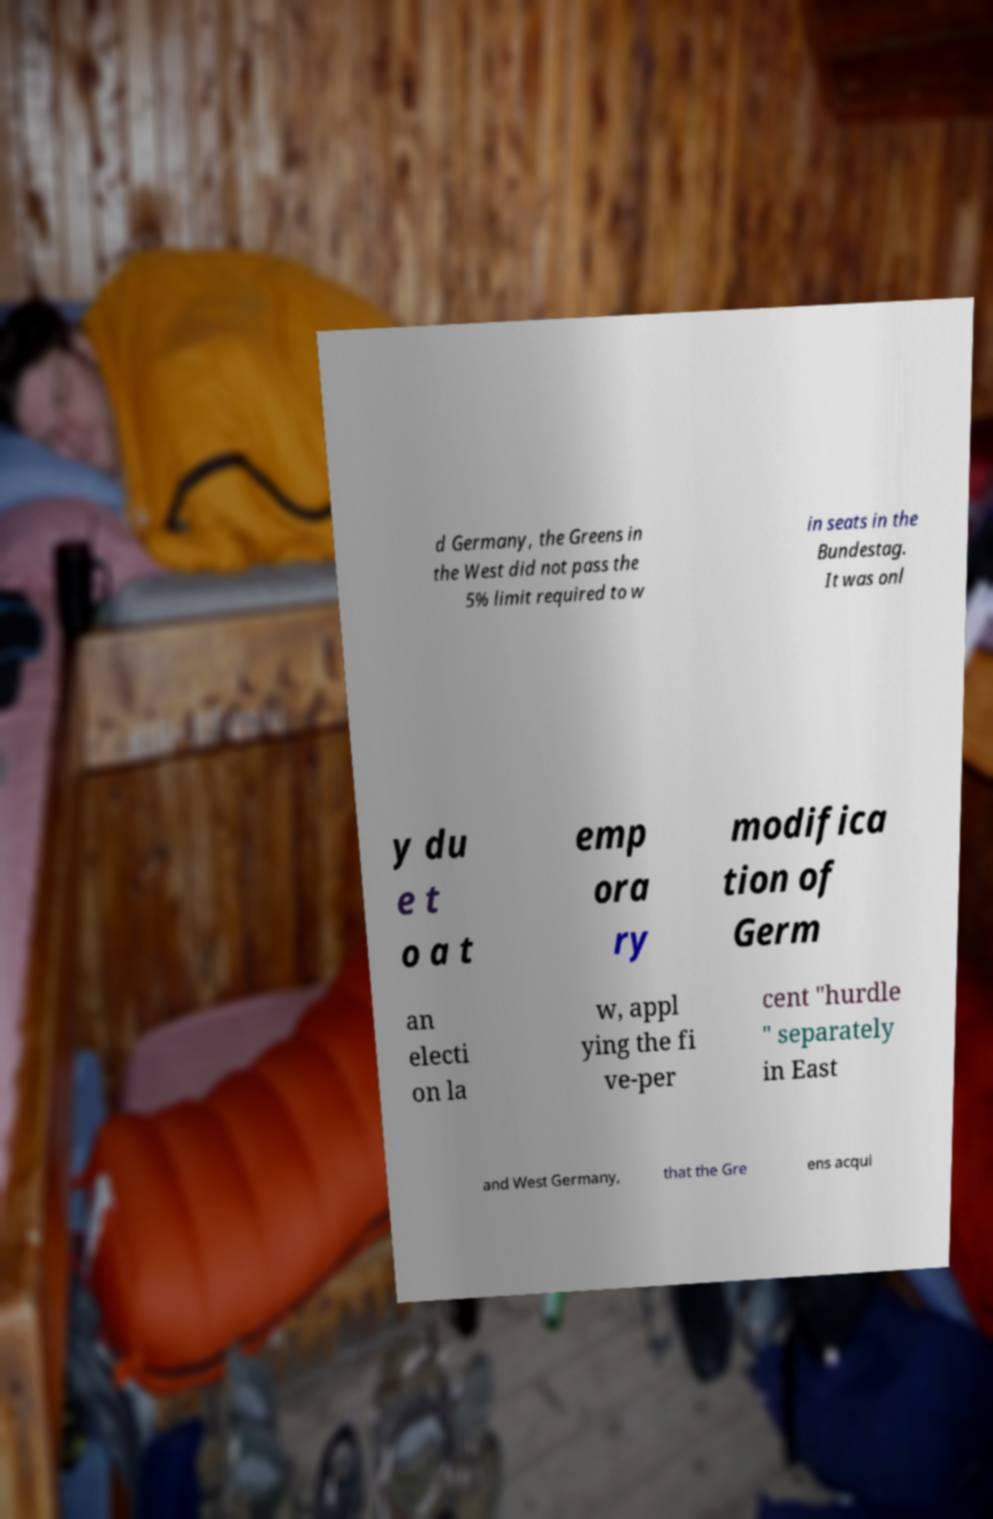Please read and relay the text visible in this image. What does it say? d Germany, the Greens in the West did not pass the 5% limit required to w in seats in the Bundestag. It was onl y du e t o a t emp ora ry modifica tion of Germ an electi on la w, appl ying the fi ve-per cent "hurdle " separately in East and West Germany, that the Gre ens acqui 